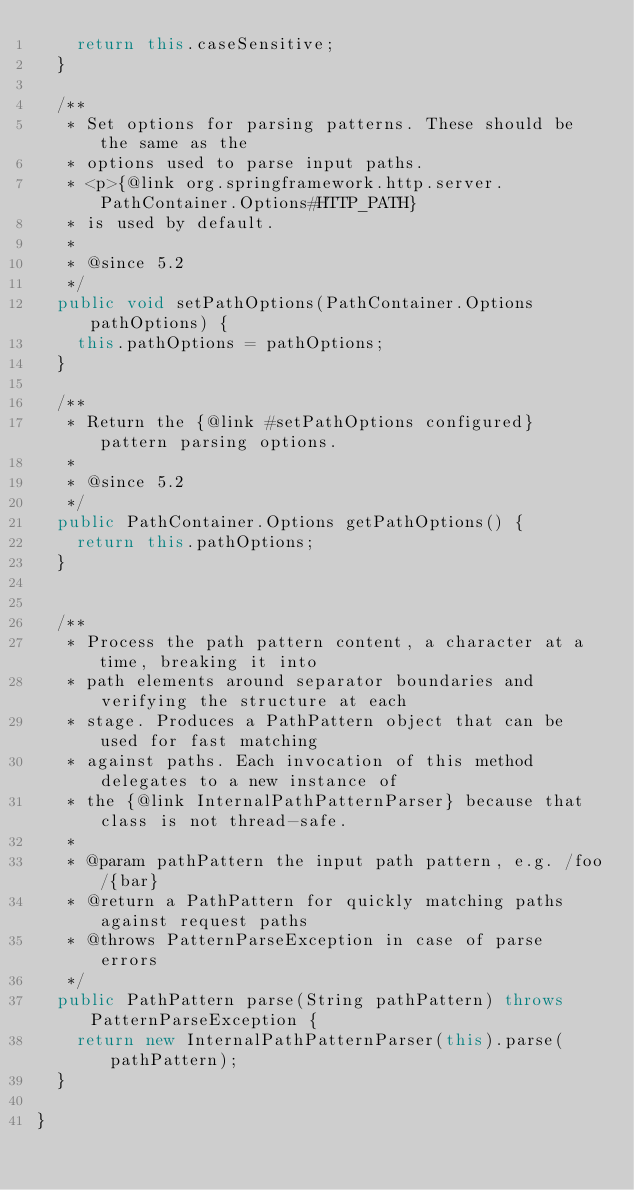Convert code to text. <code><loc_0><loc_0><loc_500><loc_500><_Java_>		return this.caseSensitive;
	}

	/**
	 * Set options for parsing patterns. These should be the same as the
	 * options used to parse input paths.
	 * <p>{@link org.springframework.http.server.PathContainer.Options#HTTP_PATH}
	 * is used by default.
	 *
	 * @since 5.2
	 */
	public void setPathOptions(PathContainer.Options pathOptions) {
		this.pathOptions = pathOptions;
	}

	/**
	 * Return the {@link #setPathOptions configured} pattern parsing options.
	 *
	 * @since 5.2
	 */
	public PathContainer.Options getPathOptions() {
		return this.pathOptions;
	}


	/**
	 * Process the path pattern content, a character at a time, breaking it into
	 * path elements around separator boundaries and verifying the structure at each
	 * stage. Produces a PathPattern object that can be used for fast matching
	 * against paths. Each invocation of this method delegates to a new instance of
	 * the {@link InternalPathPatternParser} because that class is not thread-safe.
	 *
	 * @param pathPattern the input path pattern, e.g. /foo/{bar}
	 * @return a PathPattern for quickly matching paths against request paths
	 * @throws PatternParseException in case of parse errors
	 */
	public PathPattern parse(String pathPattern) throws PatternParseException {
		return new InternalPathPatternParser(this).parse(pathPattern);
	}

}
</code> 